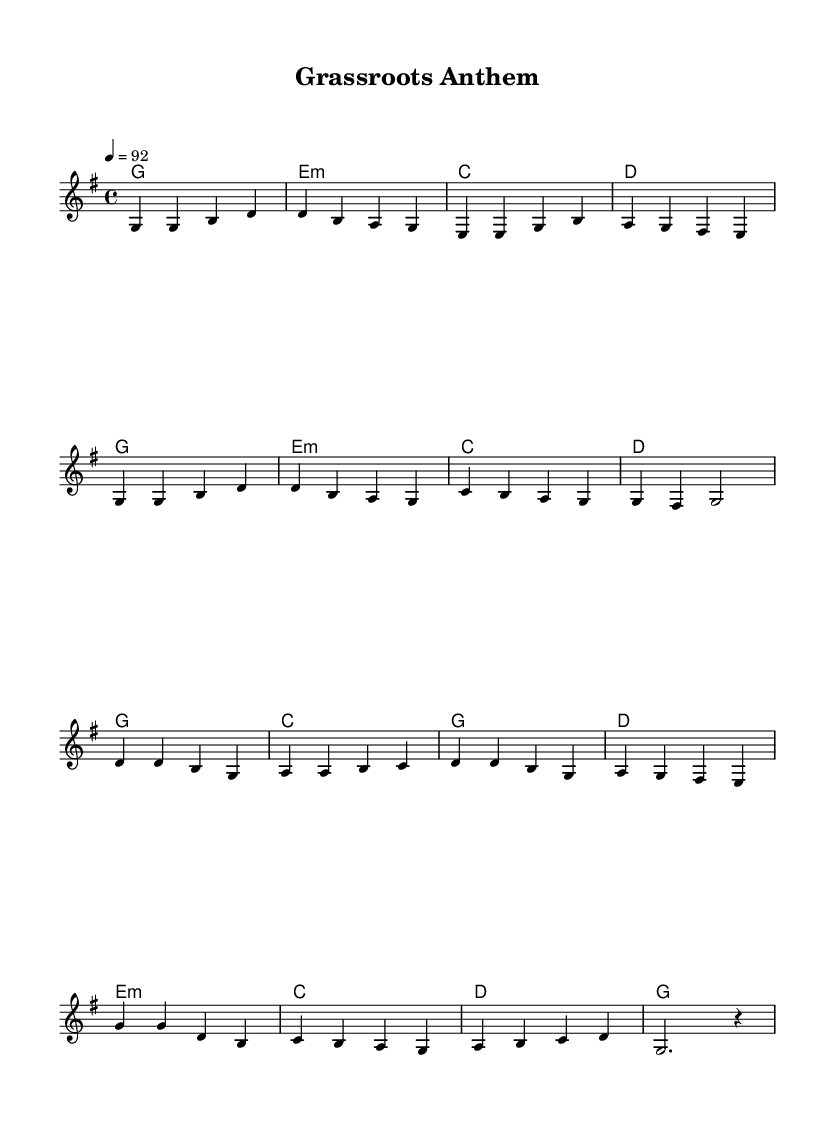What is the key signature of this music? The key signature is G major, which has one sharp (F#). This is determined by the identifying the "key" in the global declaration section of the code.
Answer: G major What is the time signature of this music? The time signature is 4/4, indicated at the beginning of the global section of the code. This time signature means there are four beats per measure and the quarter note gets one beat.
Answer: 4/4 What is the tempo of the piece? The tempo is set to 92 beats per minute, as indicated by the tempo marking in the global section of the code. This indicates the speed at which the piece should be performed.
Answer: 92 How many measures are in the verse section? There are eight measures in the verse section, as counted from the melody data provided. This section is separated by the comments indicating "Verse."
Answer: 8 What primary chords are used in the verse? The primary chords used in the verse are G, E minor, C, and D. This is derived from the chord progressions laid out in the harmonies section of the code.
Answer: G, E minor, C, D What motif could represent community service in this piece? The repetitive, uplifting melodic phrases alongside the major chords suggest a spirit of togetherness and shared effort, characteristic of themes found in country rock relating to community service. This is drawn from the overall feel conveyed through the chord and melody combination.
Answer: Togetherness 